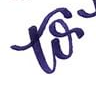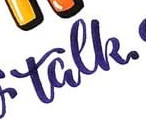Transcribe the words shown in these images in order, separated by a semicolon. to; talk 